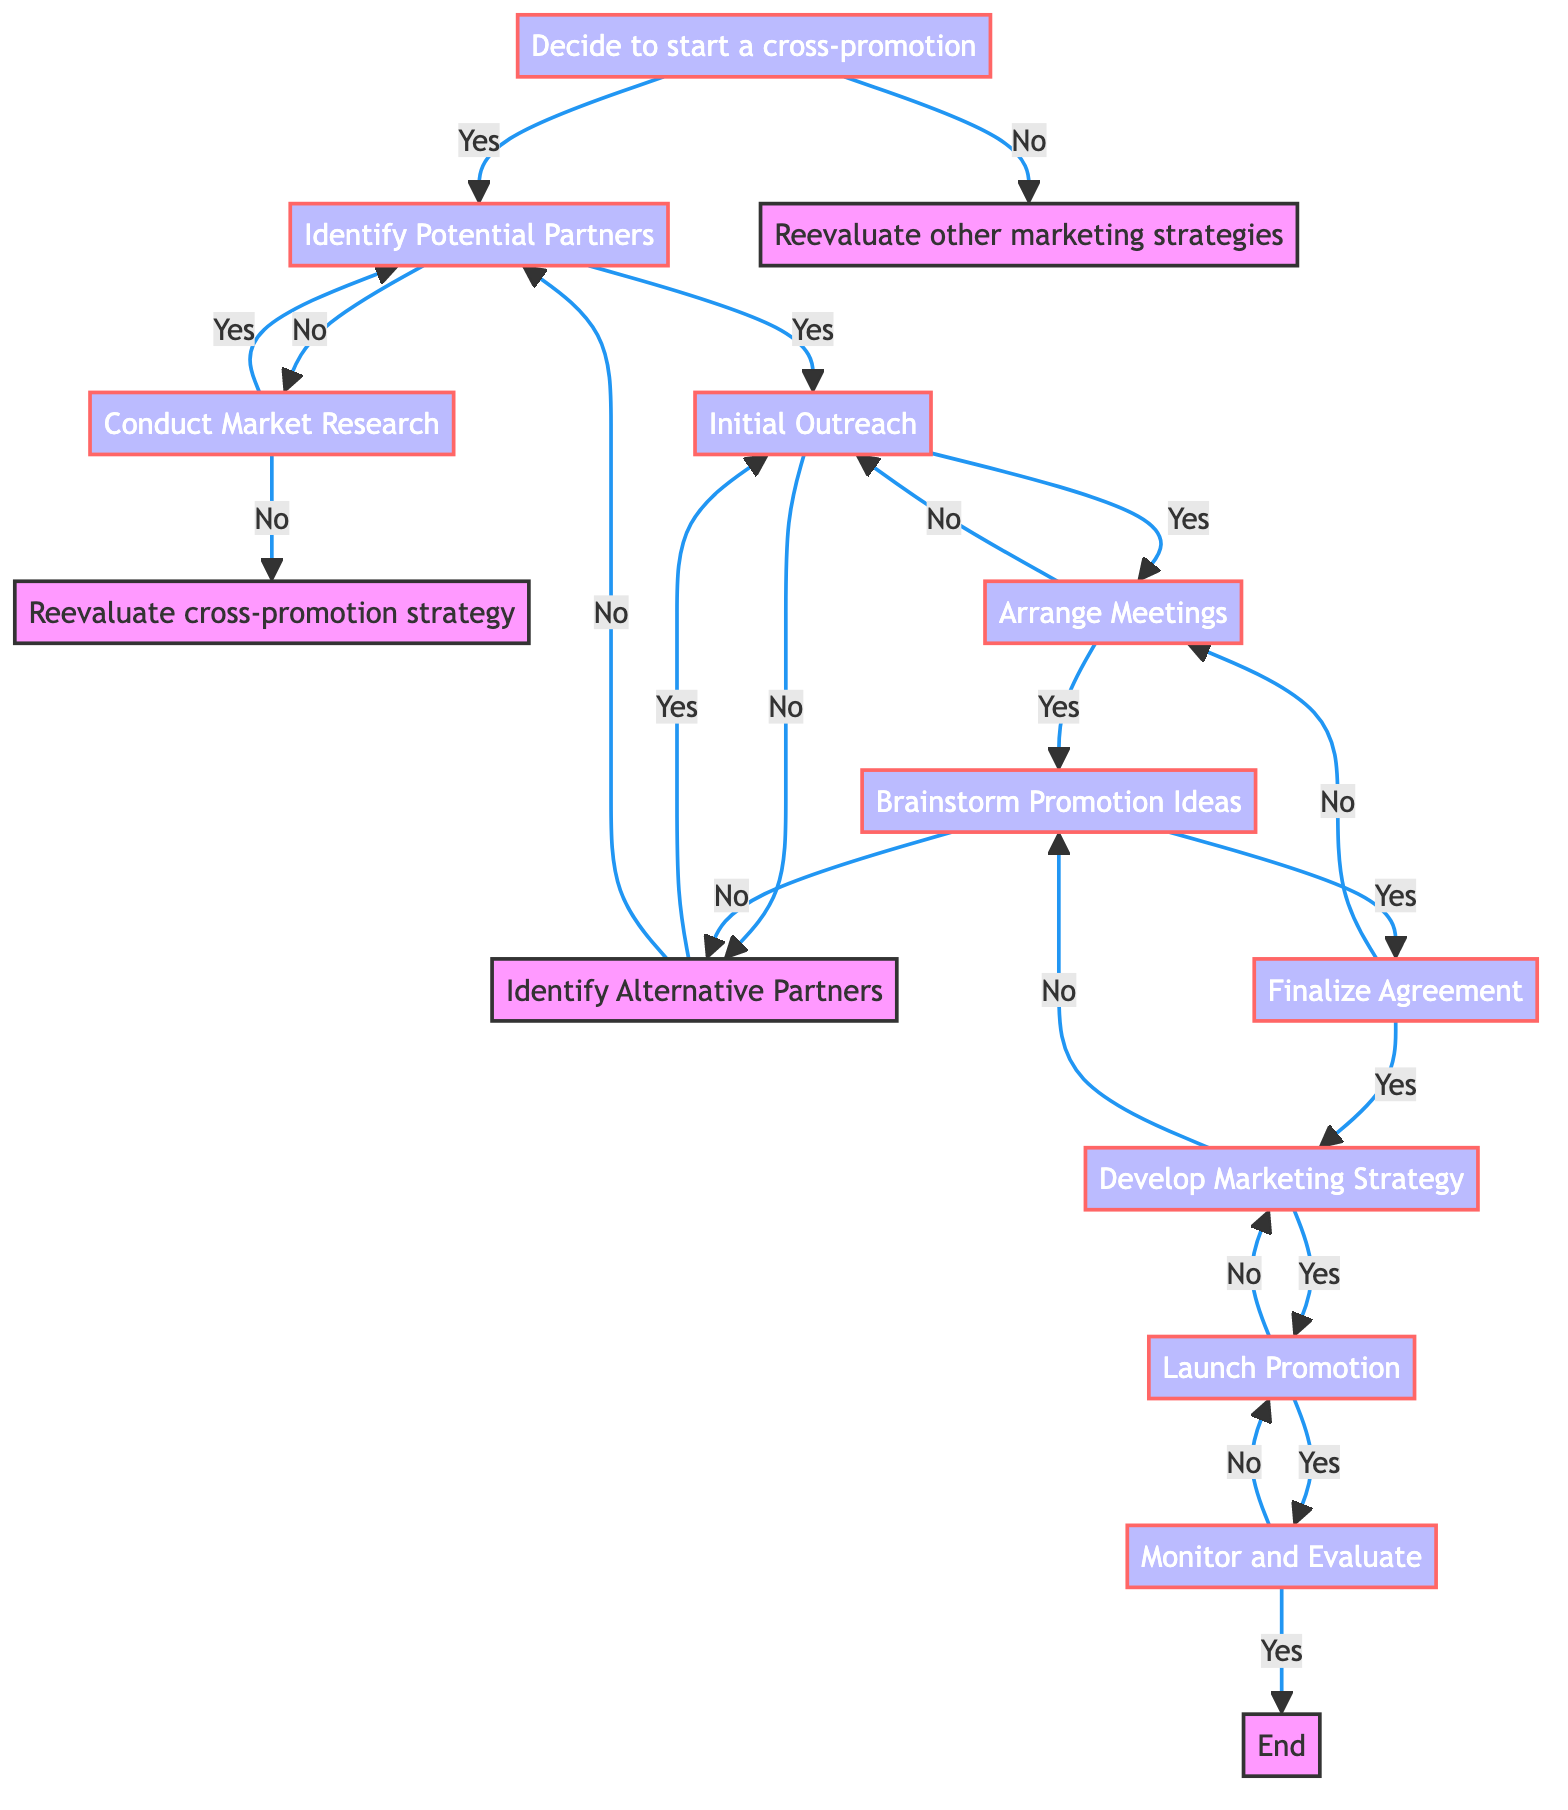What is the first step in the cross-promotion process? The first step is indicated by the start node which is "Decide to start a cross-promotion."
Answer: Decide to start a cross-promotion How many main options are presented after the initial decision to start a cross-promotion? The diagram shows two options: "Identify Potential Partners" and "Reevaluate other marketing strategies."
Answer: Two What happens if you choose "No" after the "Initial Outreach"? If "No" is chosen at "Initial Outreach," it leads to "Identify Alternative Partners."
Answer: Identify Alternative Partners What is the final step once the promotion has been launched? The last node in the process after launching the promotion is "Monitor and Evaluate," which then leads to "End."
Answer: Monitor and Evaluate How does "Conduct Market Research" relate to the flow of the process? "Conduct Market Research" revisits the step to "Identify Potential Partners" if the answer is "Yes," and if "No," it leads to "Reevaluate cross-promotion strategy."
Answer: It relates to "Identify Potential Partners" and "Reevaluate cross-promotion strategy" What will you do after brainstorming promotion ideas if you end up with "No"? If the answer is "No" after brainstorming, you return to "Identify Alternative Partners."
Answer: Identify Alternative Partners If you successfully develop a marketing strategy, which step follows next? Following the successful development of a marketing strategy, you proceed to "Launch Promotion."
Answer: Launch Promotion What node comes directly after "Finalize Agreement"? The node directly following "Finalize Agreement" is "Develop Marketing Strategy."
Answer: Develop Marketing Strategy What options do you have if you do not successfully arrange meetings? Not successfully arranging meetings leads you back to "Initial Outreach."
Answer: Initial Outreach 